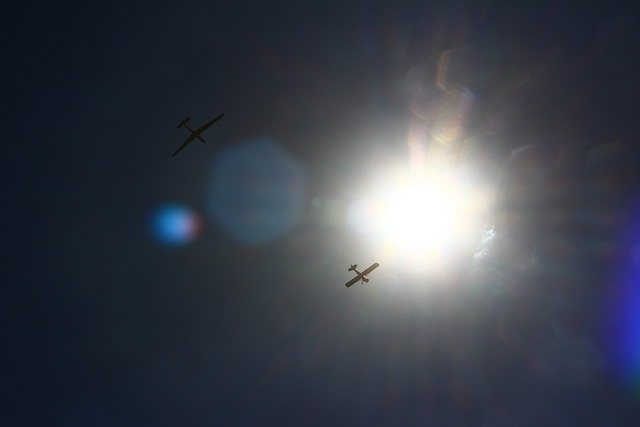Describe the objects in this image and their specific colors. I can see airplane in black tones and airplane in black, gray, and darkgray tones in this image. 